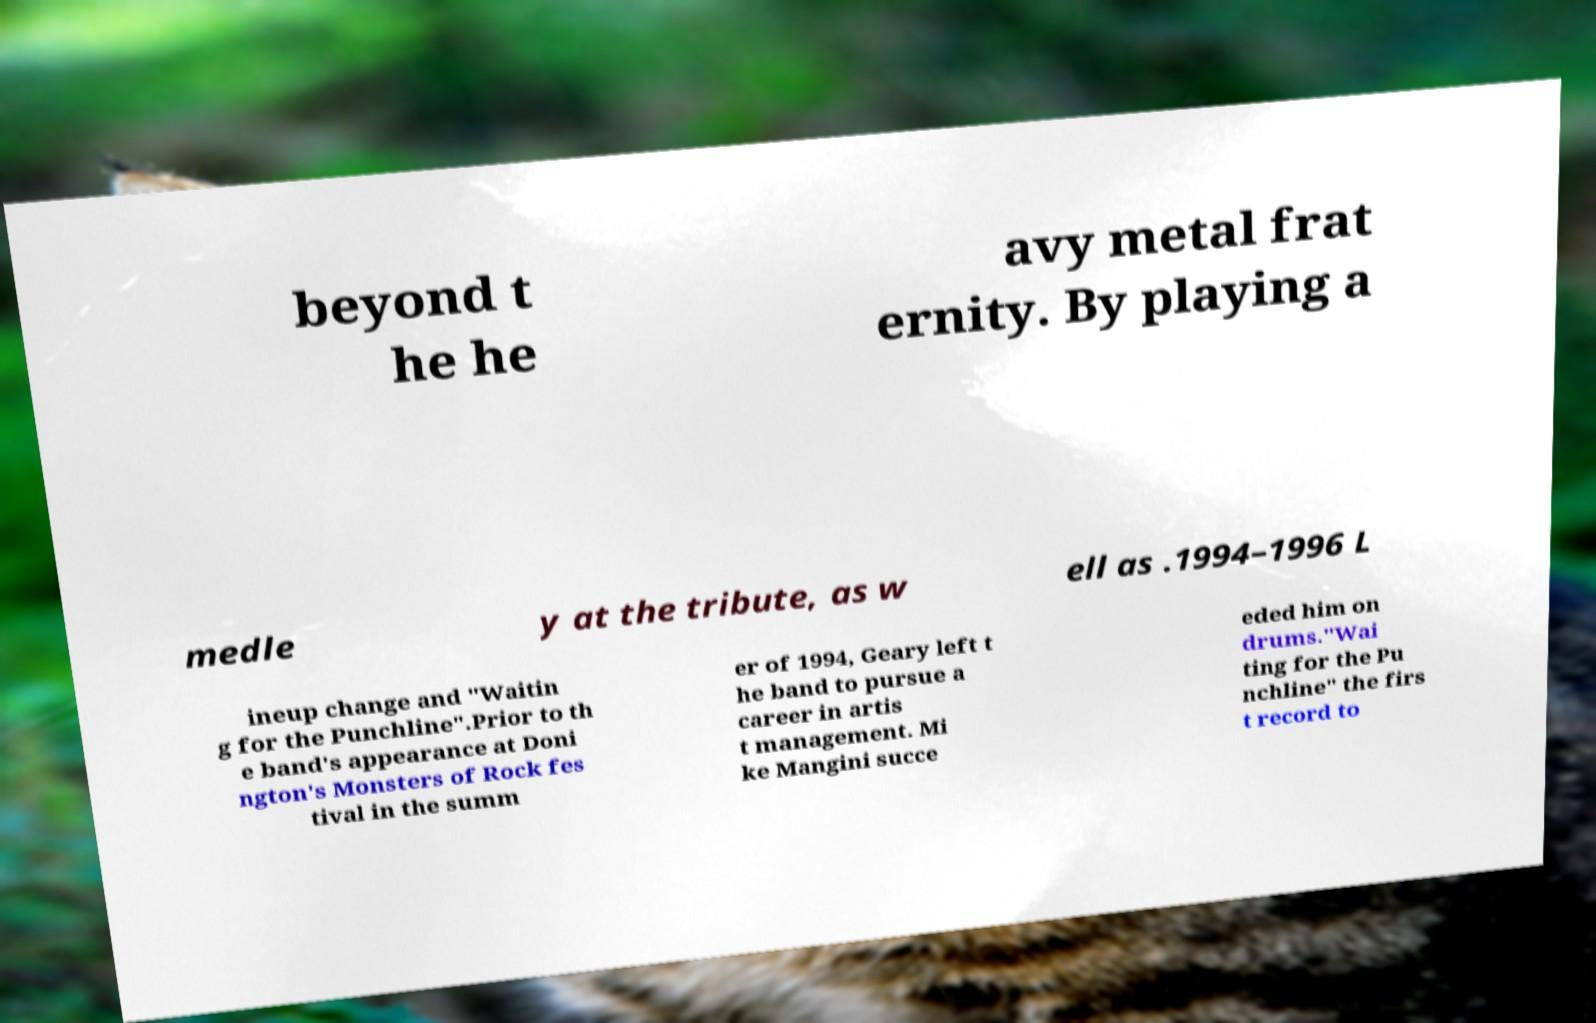Could you assist in decoding the text presented in this image and type it out clearly? beyond t he he avy metal frat ernity. By playing a medle y at the tribute, as w ell as .1994–1996 L ineup change and "Waitin g for the Punchline".Prior to th e band's appearance at Doni ngton's Monsters of Rock fes tival in the summ er of 1994, Geary left t he band to pursue a career in artis t management. Mi ke Mangini succe eded him on drums."Wai ting for the Pu nchline" the firs t record to 